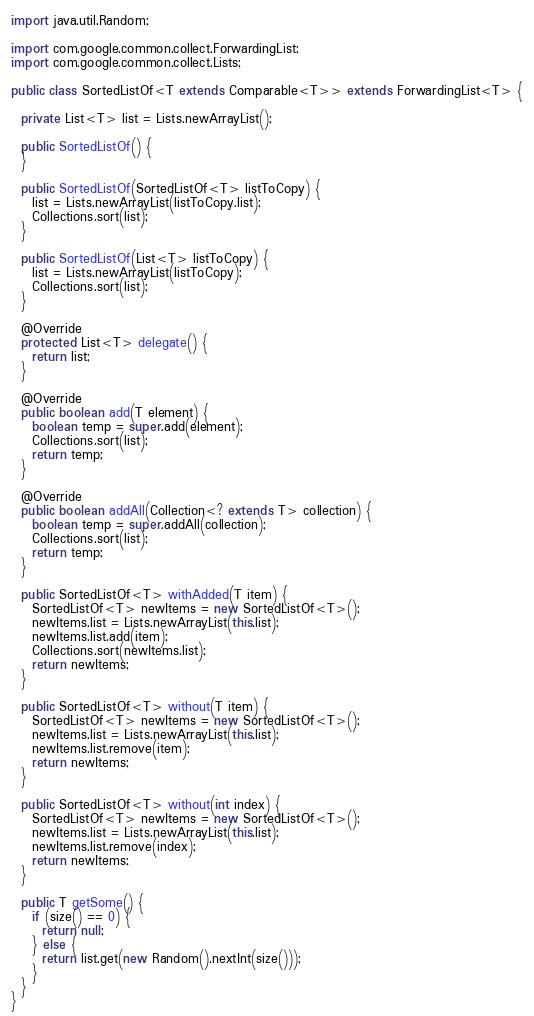<code> <loc_0><loc_0><loc_500><loc_500><_Java_>import java.util.Random;

import com.google.common.collect.ForwardingList;
import com.google.common.collect.Lists;

public class SortedListOf<T extends Comparable<T>> extends ForwardingList<T> {

  private List<T> list = Lists.newArrayList();
  
  public SortedListOf() {
  }

  public SortedListOf(SortedListOf<T> listToCopy) {
    list = Lists.newArrayList(listToCopy.list);
    Collections.sort(list);
  }

  public SortedListOf(List<T> listToCopy) {
    list = Lists.newArrayList(listToCopy);
    Collections.sort(list);
  }

  @Override
  protected List<T> delegate() {
    return list;
  }

  @Override
  public boolean add(T element) {
    boolean temp = super.add(element);
    Collections.sort(list);
    return temp;
  }

  @Override
  public boolean addAll(Collection<? extends T> collection) {
    boolean temp = super.addAll(collection);
    Collections.sort(list);
    return temp;
  }

  public SortedListOf<T> withAdded(T item) {
    SortedListOf<T> newItems = new SortedListOf<T>();
    newItems.list = Lists.newArrayList(this.list);
    newItems.list.add(item);
    Collections.sort(newItems.list);
    return newItems;
  }

  public SortedListOf<T> without(T item) {
    SortedListOf<T> newItems = new SortedListOf<T>();
    newItems.list = Lists.newArrayList(this.list);
    newItems.list.remove(item);
    return newItems;
  }

  public SortedListOf<T> without(int index) {
    SortedListOf<T> newItems = new SortedListOf<T>();
    newItems.list = Lists.newArrayList(this.list);
    newItems.list.remove(index);
    return newItems;
  }

  public T getSome() {
    if (size() == 0) {
      return null;
    } else {
      return list.get(new Random().nextInt(size()));
    }
  }
}</code> 